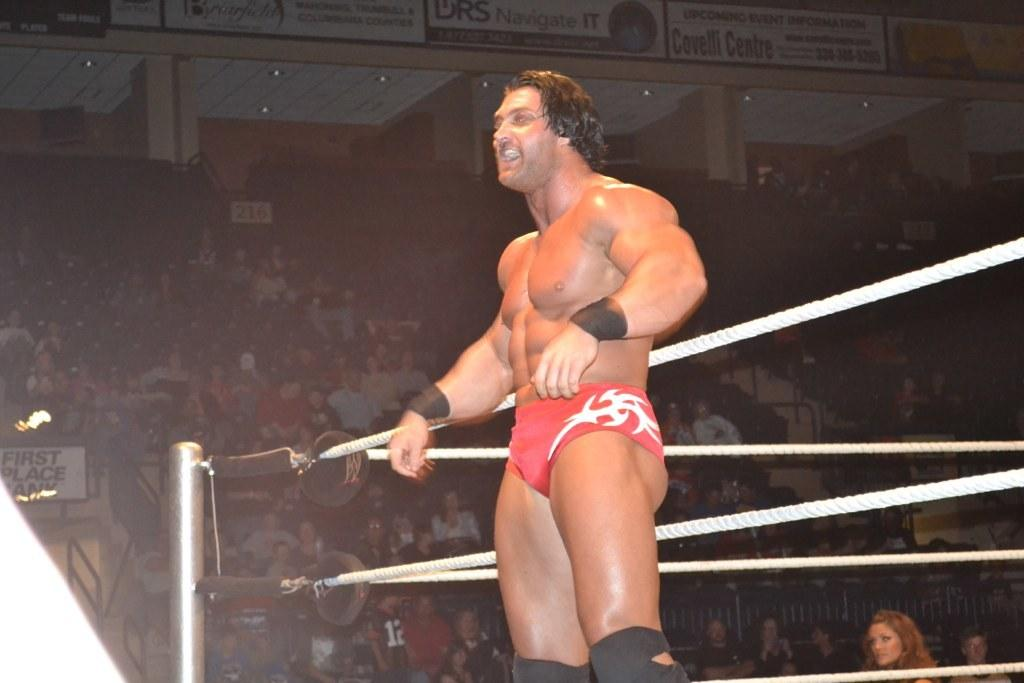<image>
Create a compact narrative representing the image presented. a man at a wrestling event with the word first in the distance 